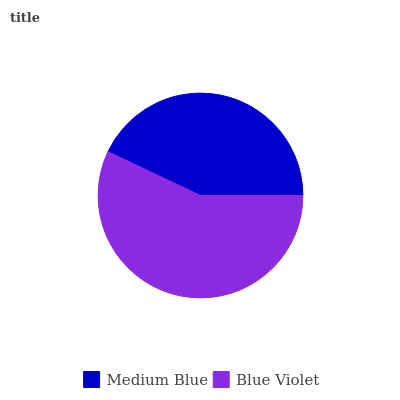Is Medium Blue the minimum?
Answer yes or no. Yes. Is Blue Violet the maximum?
Answer yes or no. Yes. Is Blue Violet the minimum?
Answer yes or no. No. Is Blue Violet greater than Medium Blue?
Answer yes or no. Yes. Is Medium Blue less than Blue Violet?
Answer yes or no. Yes. Is Medium Blue greater than Blue Violet?
Answer yes or no. No. Is Blue Violet less than Medium Blue?
Answer yes or no. No. Is Blue Violet the high median?
Answer yes or no. Yes. Is Medium Blue the low median?
Answer yes or no. Yes. Is Medium Blue the high median?
Answer yes or no. No. Is Blue Violet the low median?
Answer yes or no. No. 